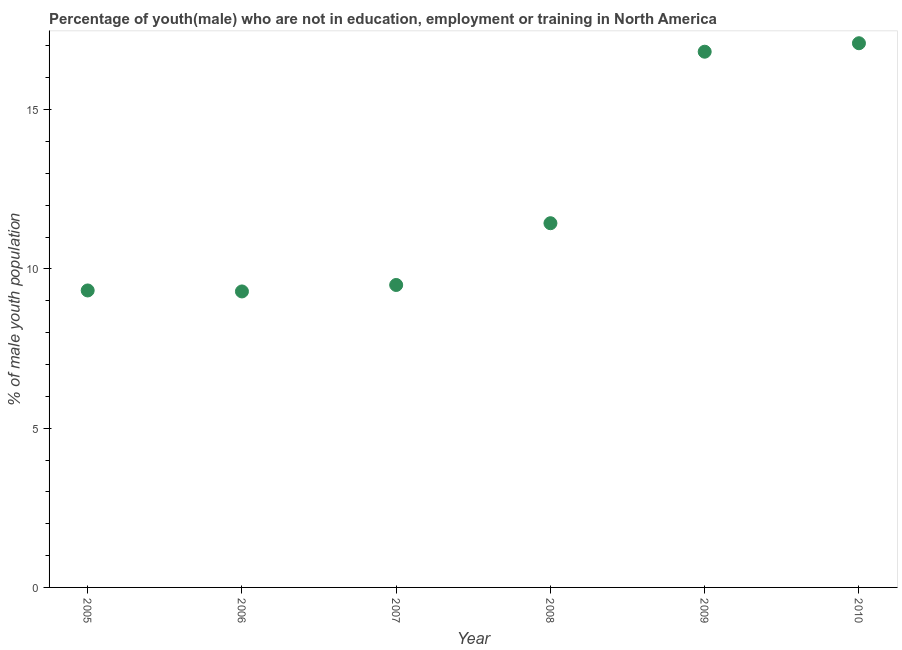What is the unemployed male youth population in 2010?
Your response must be concise. 17.08. Across all years, what is the maximum unemployed male youth population?
Your answer should be compact. 17.08. Across all years, what is the minimum unemployed male youth population?
Your response must be concise. 9.29. In which year was the unemployed male youth population minimum?
Your answer should be very brief. 2006. What is the sum of the unemployed male youth population?
Make the answer very short. 73.45. What is the difference between the unemployed male youth population in 2005 and 2008?
Your response must be concise. -2.11. What is the average unemployed male youth population per year?
Provide a short and direct response. 12.24. What is the median unemployed male youth population?
Make the answer very short. 10.46. Do a majority of the years between 2005 and 2010 (inclusive) have unemployed male youth population greater than 4 %?
Keep it short and to the point. Yes. What is the ratio of the unemployed male youth population in 2007 to that in 2010?
Your response must be concise. 0.56. Is the unemployed male youth population in 2005 less than that in 2008?
Ensure brevity in your answer.  Yes. What is the difference between the highest and the second highest unemployed male youth population?
Make the answer very short. 0.27. Is the sum of the unemployed male youth population in 2007 and 2009 greater than the maximum unemployed male youth population across all years?
Your response must be concise. Yes. What is the difference between the highest and the lowest unemployed male youth population?
Your answer should be very brief. 7.79. In how many years, is the unemployed male youth population greater than the average unemployed male youth population taken over all years?
Keep it short and to the point. 2. Are the values on the major ticks of Y-axis written in scientific E-notation?
Offer a very short reply. No. Does the graph contain any zero values?
Offer a very short reply. No. What is the title of the graph?
Give a very brief answer. Percentage of youth(male) who are not in education, employment or training in North America. What is the label or title of the Y-axis?
Your answer should be compact. % of male youth population. What is the % of male youth population in 2005?
Keep it short and to the point. 9.32. What is the % of male youth population in 2006?
Provide a short and direct response. 9.29. What is the % of male youth population in 2007?
Provide a succinct answer. 9.5. What is the % of male youth population in 2008?
Your response must be concise. 11.43. What is the % of male youth population in 2009?
Provide a short and direct response. 16.82. What is the % of male youth population in 2010?
Keep it short and to the point. 17.08. What is the difference between the % of male youth population in 2005 and 2006?
Your answer should be very brief. 0.03. What is the difference between the % of male youth population in 2005 and 2007?
Provide a succinct answer. -0.17. What is the difference between the % of male youth population in 2005 and 2008?
Your response must be concise. -2.11. What is the difference between the % of male youth population in 2005 and 2009?
Your answer should be compact. -7.5. What is the difference between the % of male youth population in 2005 and 2010?
Provide a succinct answer. -7.76. What is the difference between the % of male youth population in 2006 and 2007?
Keep it short and to the point. -0.2. What is the difference between the % of male youth population in 2006 and 2008?
Offer a very short reply. -2.14. What is the difference between the % of male youth population in 2006 and 2009?
Give a very brief answer. -7.53. What is the difference between the % of male youth population in 2006 and 2010?
Your response must be concise. -7.79. What is the difference between the % of male youth population in 2007 and 2008?
Offer a very short reply. -1.94. What is the difference between the % of male youth population in 2007 and 2009?
Offer a very short reply. -7.32. What is the difference between the % of male youth population in 2007 and 2010?
Ensure brevity in your answer.  -7.59. What is the difference between the % of male youth population in 2008 and 2009?
Your answer should be very brief. -5.38. What is the difference between the % of male youth population in 2008 and 2010?
Give a very brief answer. -5.65. What is the difference between the % of male youth population in 2009 and 2010?
Your answer should be very brief. -0.27. What is the ratio of the % of male youth population in 2005 to that in 2006?
Your answer should be very brief. 1. What is the ratio of the % of male youth population in 2005 to that in 2007?
Offer a terse response. 0.98. What is the ratio of the % of male youth population in 2005 to that in 2008?
Provide a short and direct response. 0.81. What is the ratio of the % of male youth population in 2005 to that in 2009?
Make the answer very short. 0.55. What is the ratio of the % of male youth population in 2005 to that in 2010?
Offer a terse response. 0.55. What is the ratio of the % of male youth population in 2006 to that in 2008?
Your answer should be compact. 0.81. What is the ratio of the % of male youth population in 2006 to that in 2009?
Your response must be concise. 0.55. What is the ratio of the % of male youth population in 2006 to that in 2010?
Give a very brief answer. 0.54. What is the ratio of the % of male youth population in 2007 to that in 2008?
Provide a short and direct response. 0.83. What is the ratio of the % of male youth population in 2007 to that in 2009?
Provide a succinct answer. 0.56. What is the ratio of the % of male youth population in 2007 to that in 2010?
Give a very brief answer. 0.56. What is the ratio of the % of male youth population in 2008 to that in 2009?
Your answer should be compact. 0.68. What is the ratio of the % of male youth population in 2008 to that in 2010?
Your answer should be compact. 0.67. 